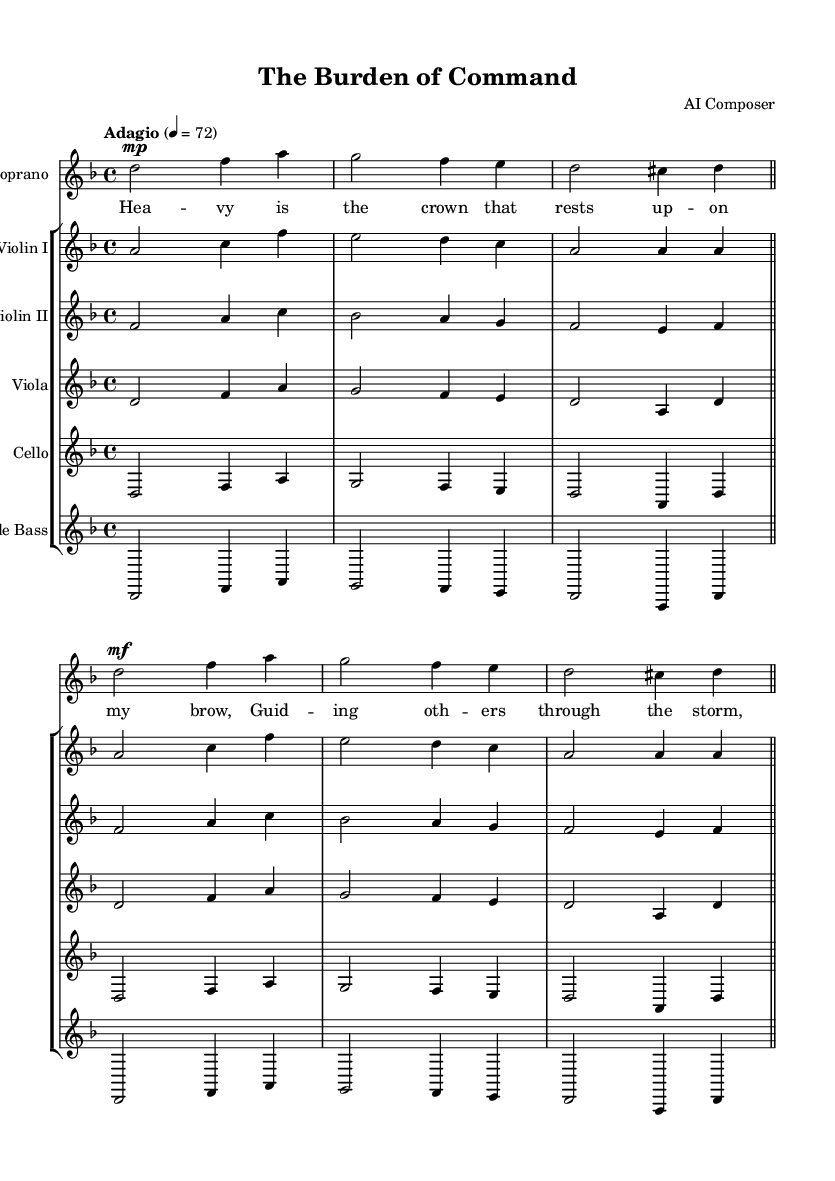What is the key signature of this music? The key signature indicated is D minor, which has one flat. In sheet music, the key signature is shown at the beginning of the staff. The presence of a flat on the B line indicates D minor specifically.
Answer: D minor What is the time signature of this piece? The time signature appears as 4/4, which is indicated by the "4/4" notation at the beginning of the score. This means there are four beats in a measure and the quarter note gets one beat.
Answer: 4/4 What is the tempo marking for this section? The tempo marking shown is "Adagio," with a metronome marking of 72 beats per minute. This indicates a slow tempo, which is common in opera to convey emotion and facilitate dramatic expression.
Answer: Adagio How many measures are present in the soprano part? The soprano part contains a total of two measures, which can be identified by the bar lines in the score. Each measure is separated by a vertical line, and there are two blocks of music in the soprano voice section.
Answer: 2 What is the main theme expressed in the lyrics? The lyrics reflect a theme of leadership and the burden that comes with guiding others. The expression "Heavy is the crown" relates to the responsibilities faced by a leader during challenging times.
Answer: Leadership Are there any instrumental sections without vocal parts? Yes, there are instrumental sections where only the strings play, specifically in the violin and viola parts, which provide harmony and support during the vocal lines. These sections are essential parts of operatic structure, where the orchestra adds depth to the narrative.
Answer: Yes 